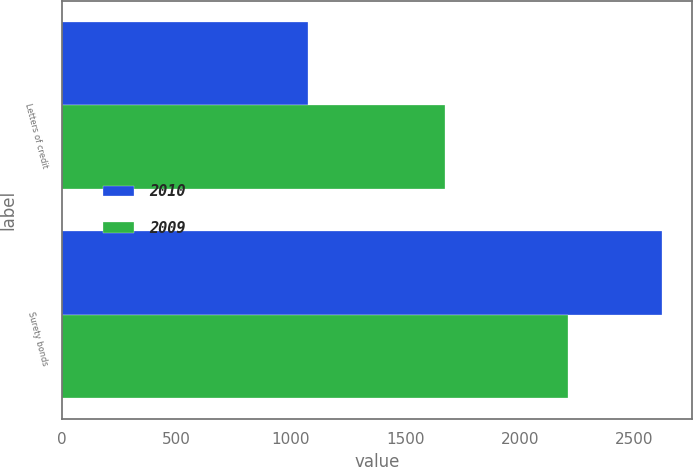Convert chart to OTSL. <chart><loc_0><loc_0><loc_500><loc_500><stacked_bar_chart><ecel><fcel>Letters of credit<fcel>Surety bonds<nl><fcel>2010<fcel>1077<fcel>2622.3<nl><fcel>2009<fcel>1673.5<fcel>2211<nl></chart> 